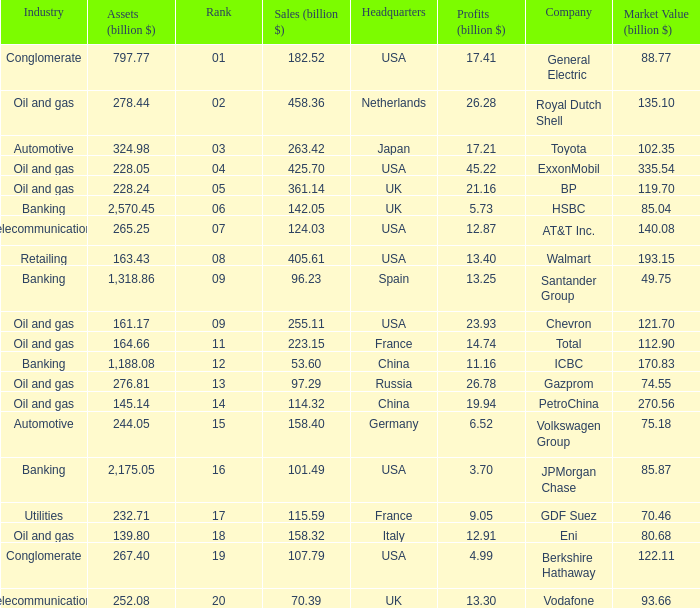How many Assets (billion $) has an Industry of oil and gas, and a Rank of 9, and a Market Value (billion $) larger than 121.7? None. 